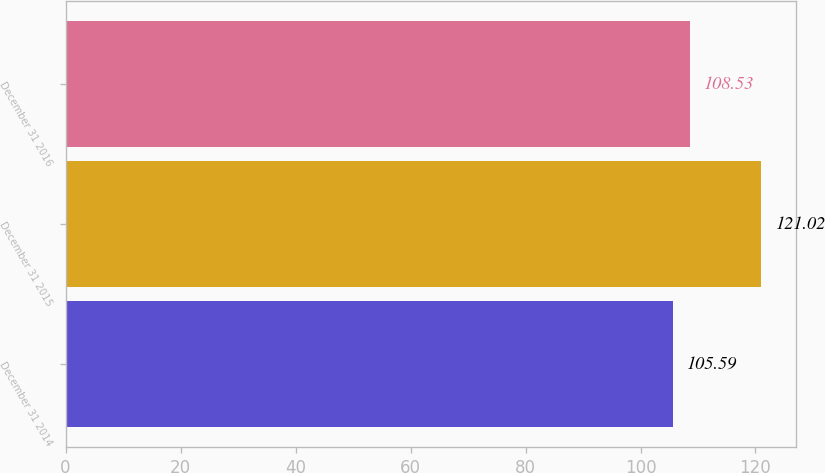Convert chart to OTSL. <chart><loc_0><loc_0><loc_500><loc_500><bar_chart><fcel>December 31 2014<fcel>December 31 2015<fcel>December 31 2016<nl><fcel>105.59<fcel>121.02<fcel>108.53<nl></chart> 